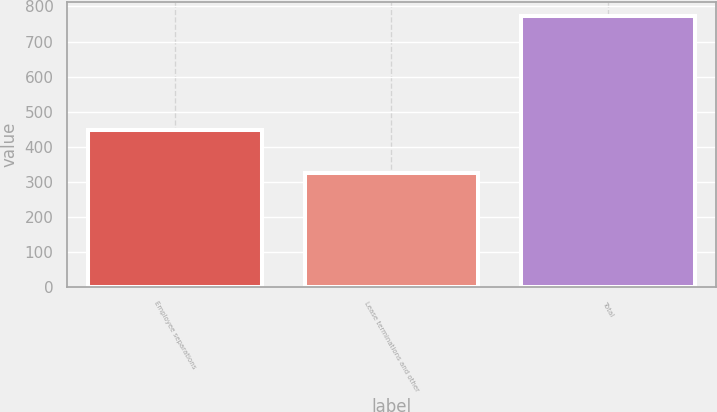Convert chart. <chart><loc_0><loc_0><loc_500><loc_500><bar_chart><fcel>Employee separations<fcel>Lease terminations and other<fcel>Total<nl><fcel>448<fcel>325<fcel>773<nl></chart> 